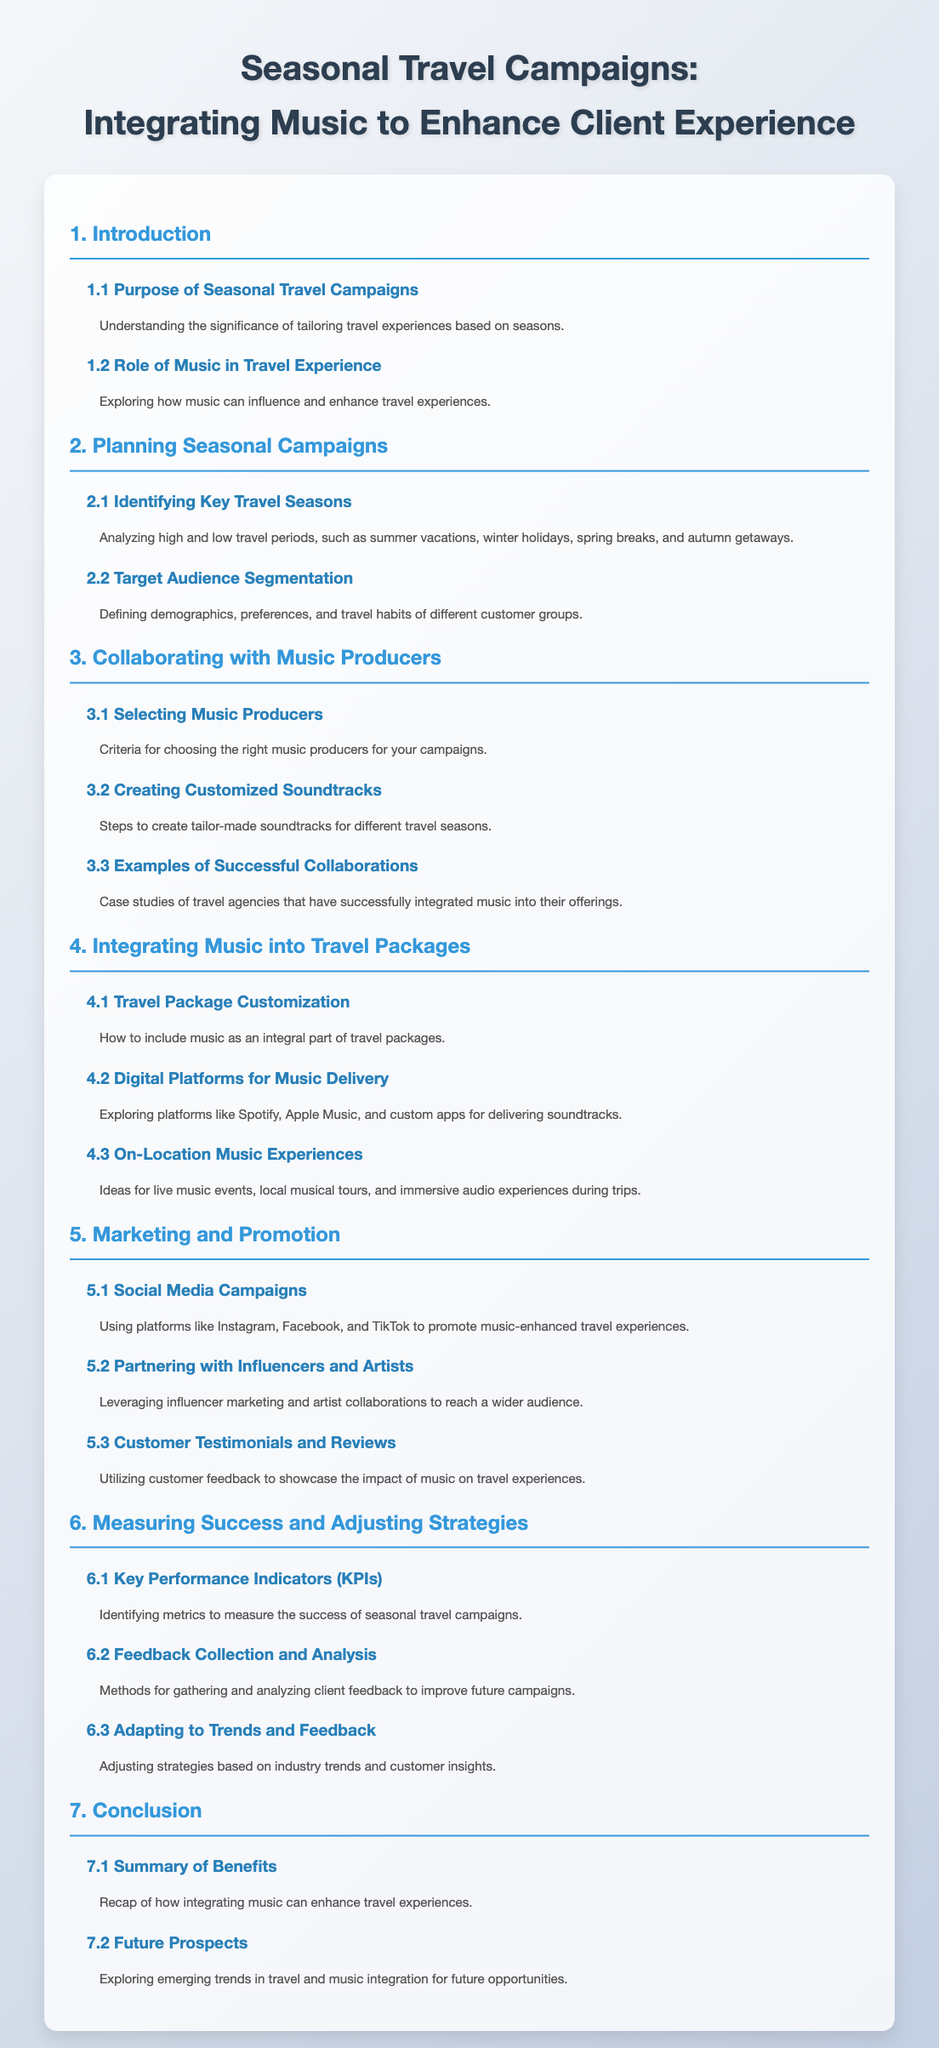What is the title of the document? The title is the main heading of the document presented at the top, which introduces the topic of seasonal travel campaigns and music integration.
Answer: Seasonal Travel Campaigns: Integrating Music to Enhance Client Experience How many main sections are there in the document? The document contains seven main sections as indicated in the Table of Contents.
Answer: 7 What is discussed in section 3.1? Section 3.1 outlines the criteria for choosing the right music producers for the campaigns.
Answer: Selecting Music Producers What is one method mentioned in section 6.2 for collecting feedback? Section 6.2 discusses gathering feedback to improve future campaigns, focusing on client insights.
Answer: Feedback Collection What does section 5.1 emphasize? Section 5.1 highlights the use of social media platforms to promote music-enhanced travel experiences.
Answer: Social Media Campaigns Which platform is suggested in section 4.2 for music delivery? Section 4.2 explores various digital platforms, focusing specifically on options for delivering soundtracks.
Answer: Spotify What is the main benefit of integrating music according to section 7.1? Section 7.1 summarizes the overall advantages associated with integrating music into travel experiences.
Answer: Enhance travel experiences What can you find in section 2.2? Section 2.2 covers defining the demographics and travel habits of different customer groups.
Answer: Target Audience Segmentation 